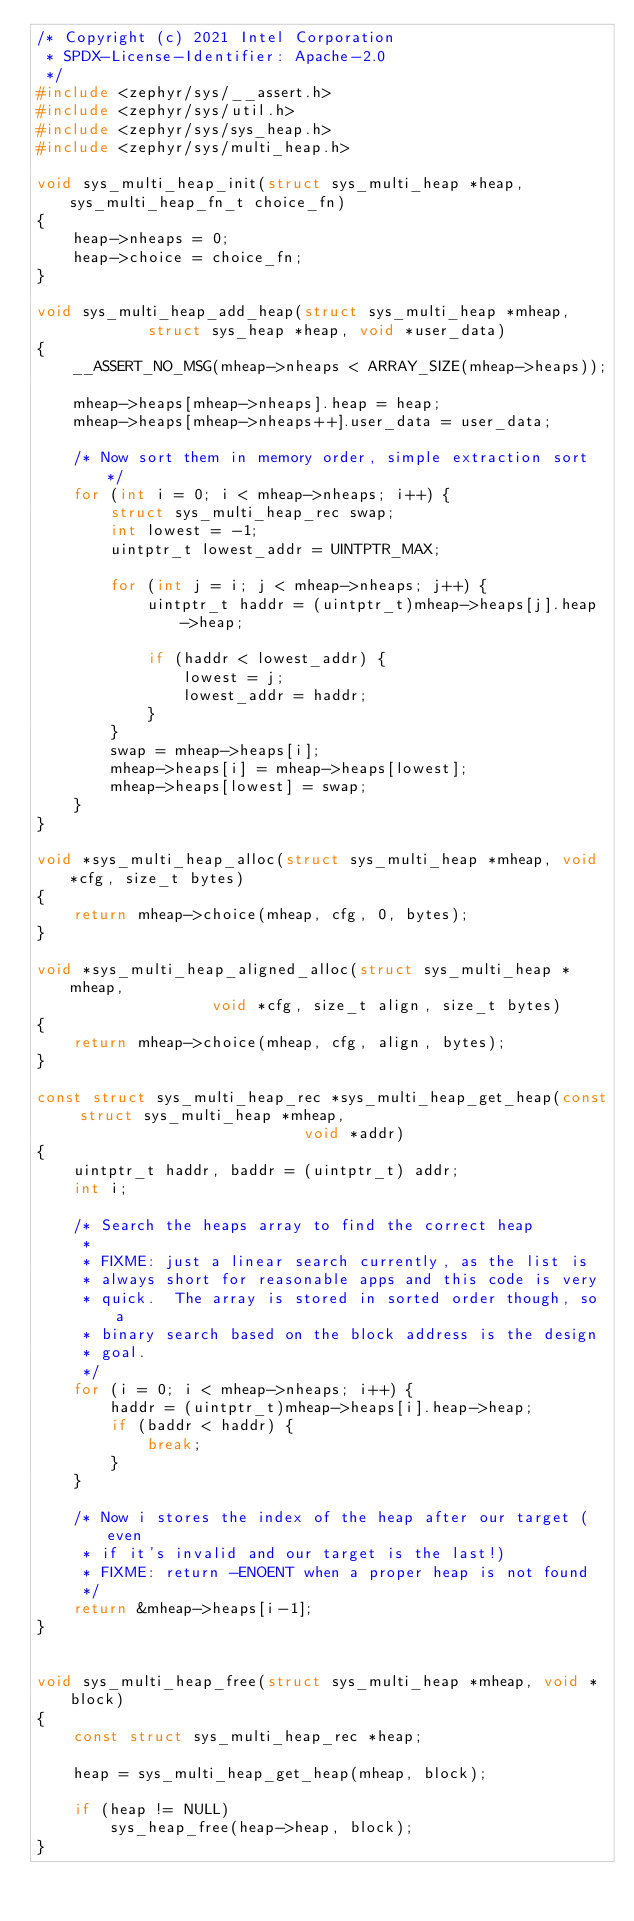<code> <loc_0><loc_0><loc_500><loc_500><_C_>/* Copyright (c) 2021 Intel Corporation
 * SPDX-License-Identifier: Apache-2.0
 */
#include <zephyr/sys/__assert.h>
#include <zephyr/sys/util.h>
#include <zephyr/sys/sys_heap.h>
#include <zephyr/sys/multi_heap.h>

void sys_multi_heap_init(struct sys_multi_heap *heap, sys_multi_heap_fn_t choice_fn)
{
	heap->nheaps = 0;
	heap->choice = choice_fn;
}

void sys_multi_heap_add_heap(struct sys_multi_heap *mheap,
			struct sys_heap *heap, void *user_data)
{
	__ASSERT_NO_MSG(mheap->nheaps < ARRAY_SIZE(mheap->heaps));

	mheap->heaps[mheap->nheaps].heap = heap;
	mheap->heaps[mheap->nheaps++].user_data = user_data;

	/* Now sort them in memory order, simple extraction sort */
	for (int i = 0; i < mheap->nheaps; i++) {
		struct sys_multi_heap_rec swap;
		int lowest = -1;
		uintptr_t lowest_addr = UINTPTR_MAX;

		for (int j = i; j < mheap->nheaps; j++) {
			uintptr_t haddr = (uintptr_t)mheap->heaps[j].heap->heap;

			if (haddr < lowest_addr) {
				lowest = j;
				lowest_addr = haddr;
			}
		}
		swap = mheap->heaps[i];
		mheap->heaps[i] = mheap->heaps[lowest];
		mheap->heaps[lowest] = swap;
	}
}

void *sys_multi_heap_alloc(struct sys_multi_heap *mheap, void *cfg, size_t bytes)
{
	return mheap->choice(mheap, cfg, 0, bytes);
}

void *sys_multi_heap_aligned_alloc(struct sys_multi_heap *mheap,
				   void *cfg, size_t align, size_t bytes)
{
	return mheap->choice(mheap, cfg, align, bytes);
}

const struct sys_multi_heap_rec *sys_multi_heap_get_heap(const struct sys_multi_heap *mheap,
							 void *addr)
{
	uintptr_t haddr, baddr = (uintptr_t) addr;
	int i;

	/* Search the heaps array to find the correct heap
	 *
	 * FIXME: just a linear search currently, as the list is
	 * always short for reasonable apps and this code is very
	 * quick.  The array is stored in sorted order though, so a
	 * binary search based on the block address is the design
	 * goal.
	 */
	for (i = 0; i < mheap->nheaps; i++) {
		haddr = (uintptr_t)mheap->heaps[i].heap->heap;
		if (baddr < haddr) {
			break;
		}
	}

	/* Now i stores the index of the heap after our target (even
	 * if it's invalid and our target is the last!)
	 * FIXME: return -ENOENT when a proper heap is not found
	 */
	return &mheap->heaps[i-1];
}


void sys_multi_heap_free(struct sys_multi_heap *mheap, void *block)
{
	const struct sys_multi_heap_rec *heap;

	heap = sys_multi_heap_get_heap(mheap, block);

	if (heap != NULL)
		sys_heap_free(heap->heap, block);
}
</code> 